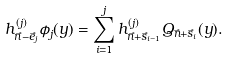<formula> <loc_0><loc_0><loc_500><loc_500>h _ { \vec { n } - \vec { e } _ { j } } ^ { ( j ) } \phi _ { j } ( y ) = \sum _ { i = 1 } ^ { j } h _ { \vec { n } + \vec { s } _ { i - 1 } } ^ { ( j ) } Q _ { \vec { n } + \vec { s } _ { i } } ( y ) .</formula> 